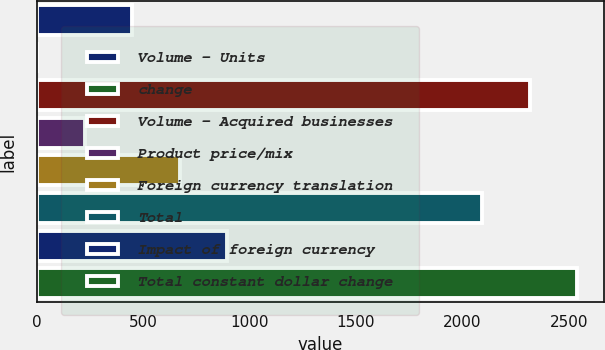Convert chart. <chart><loc_0><loc_0><loc_500><loc_500><bar_chart><fcel>Volume - Units<fcel>change<fcel>Volume - Acquired businesses<fcel>Product price/mix<fcel>Foreign currency translation<fcel>Total<fcel>Impact of foreign currency<fcel>Total constant dollar change<nl><fcel>448.96<fcel>1.7<fcel>2315.53<fcel>225.33<fcel>672.59<fcel>2091.9<fcel>896.22<fcel>2539.16<nl></chart> 